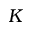Convert formula to latex. <formula><loc_0><loc_0><loc_500><loc_500>K</formula> 